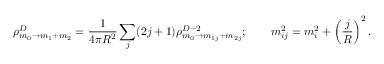Convert formula to latex. <formula><loc_0><loc_0><loc_500><loc_500>\rho _ { m _ { 0 } \rightarrow m _ { 1 } + m _ { 2 } } ^ { D } = \frac { 1 } { 4 \pi R ^ { 2 } } \sum _ { j } ( 2 j + 1 ) \rho _ { m _ { 0 } \rightarrow m _ { 1 j } + m _ { 2 j } } ^ { D - 2 } ; \quad m _ { i j } ^ { 2 } = m _ { i } ^ { 2 } + \left ( \frac { j } { R } \right ) ^ { 2 } .</formula> 